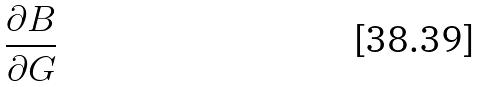<formula> <loc_0><loc_0><loc_500><loc_500>\frac { \partial B } { \partial G }</formula> 